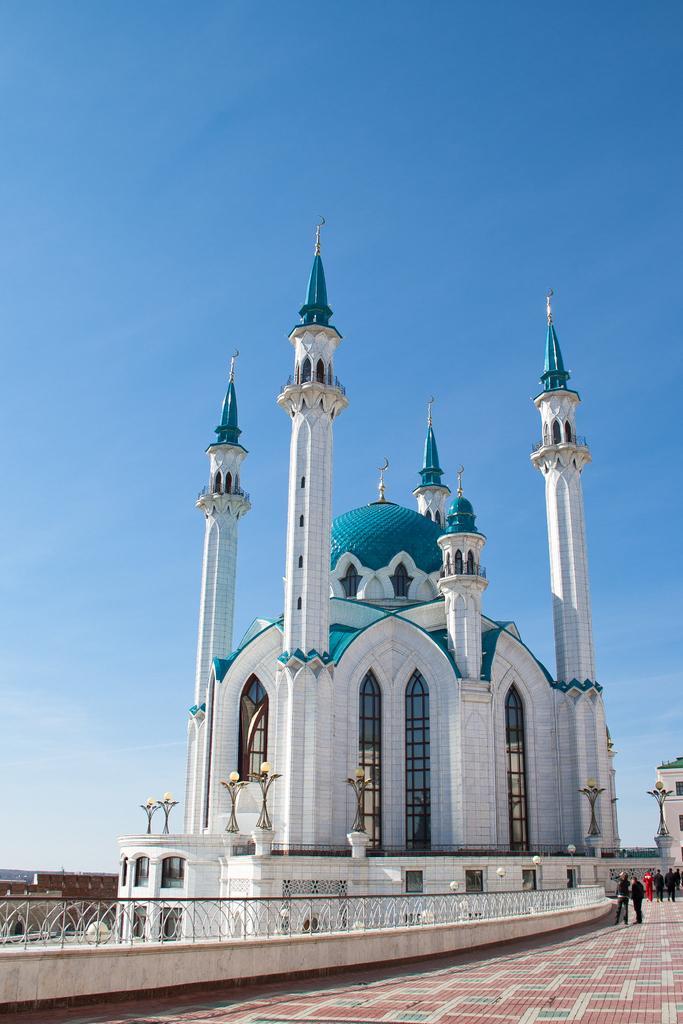Could you give a brief overview of what you see in this image? In this image I see a building which is of white and blue in color and I see the wall over here and on the path I see few people and I can also see the light bulbs on the poles. In the background I see the sky which is clear. 